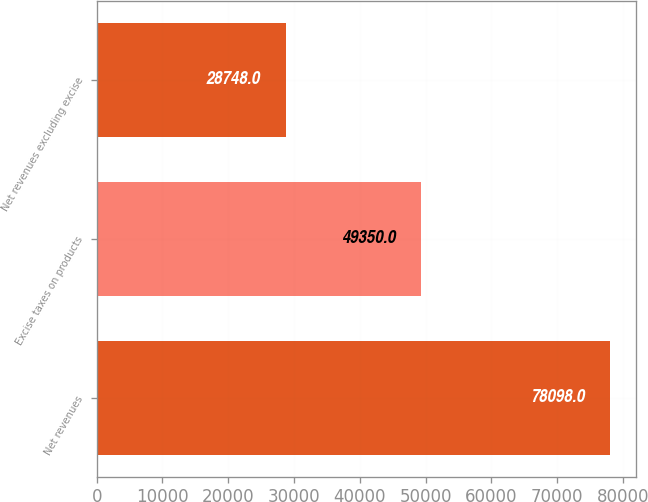<chart> <loc_0><loc_0><loc_500><loc_500><bar_chart><fcel>Net revenues<fcel>Excise taxes on products<fcel>Net revenues excluding excise<nl><fcel>78098<fcel>49350<fcel>28748<nl></chart> 